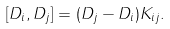<formula> <loc_0><loc_0><loc_500><loc_500>[ D _ { i } , D _ { j } ] = ( D _ { j } - D _ { i } ) K _ { i j } .</formula> 